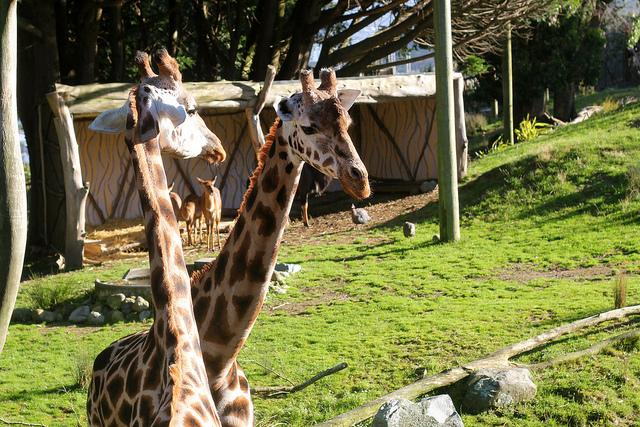Where are these giraffes?
Short answer required. Zoo. Are the giraffes standing next to each other?
Keep it brief. Yes. Is there an enclosure behind them?
Answer briefly. Yes. 